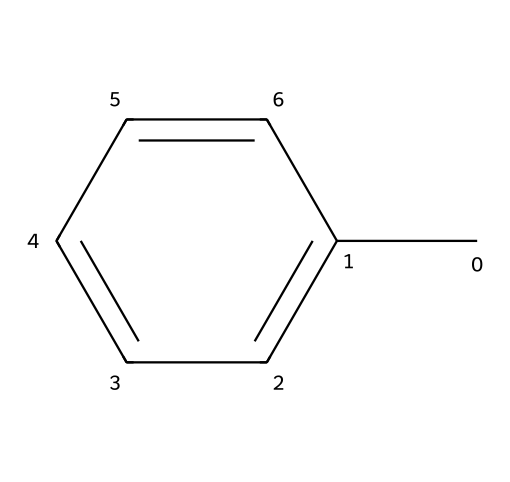What is the name of this compound? The SMILES notation "Cc1ccccc1" indicates a benzene ring with a single methyl group attached. This represents toluene, which is a common aromatic compound.
Answer: toluene How many carbon atoms are in toluene? In the SMILES representation "Cc1ccccc1", the compound contains a benzene ring (6 carbon atoms) and one methyl group (1 carbon atom), summing to 7 carbon atoms.
Answer: 7 What type of structure does toluene have? The depiction of toluene in the SMILES form shows it having a cyclic structure with alternating double bonds, characteristic of aromatic compounds.
Answer: aromatic How many hydrogen atoms are in toluene? Starting with the 7 carbon atoms in toluene, and knowing that each carbon typically bonds with one hydrogen atom in a methyl group and five in the aromatic ring, the total count of hydrogen atoms is 8.
Answer: 8 Is toluene a polar or nonpolar compound? The symmetrical shape of the toluene molecule and the presence of the nonpolar CH3 group contribute to its overall nonpolar characteristics.
Answer: nonpolar What type of reactions can toluene undergo? Toluene, due to its aromatic nature, primarily participates in electrophilic substitution reactions such as nitration and sulfonation rather than addition reactions.
Answer: electrophilic substitution What is the main use of toluene in lock degreasing products? Toluene is an effective solvent due to its ability to dissolve oils and greases, which is critical for cleaning and degreasing lock mechanisms.
Answer: solvent 